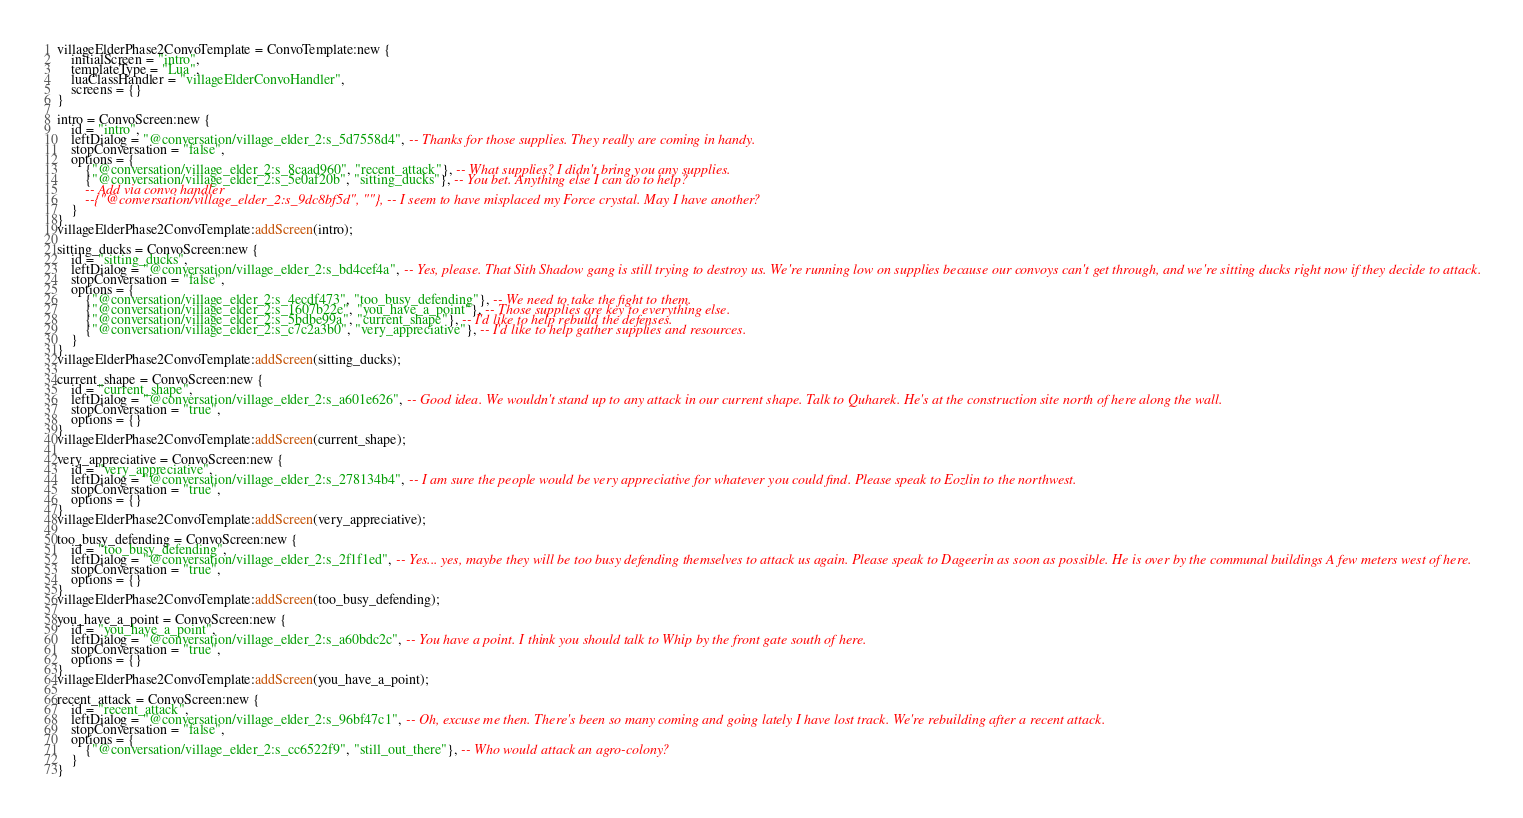<code> <loc_0><loc_0><loc_500><loc_500><_Lua_>villageElderPhase2ConvoTemplate = ConvoTemplate:new {
	initialScreen = "intro",
	templateType = "Lua",
	luaClassHandler = "villageElderConvoHandler",
	screens = {}
}

intro = ConvoScreen:new {
	id = "intro",
	leftDialog = "@conversation/village_elder_2:s_5d7558d4", -- Thanks for those supplies. They really are coming in handy.
	stopConversation = "false",
	options = {
		{"@conversation/village_elder_2:s_8caad960", "recent_attack"}, -- What supplies? I didn't bring you any supplies.
		{"@conversation/village_elder_2:s_5e0af20b", "sitting_ducks"}, -- You bet. Anything else I can do to help?
		-- Add via convo handler
		--{"@conversation/village_elder_2:s_9dc8bf5d", ""}, -- I seem to have misplaced my Force crystal. May I have another?
	}
}
villageElderPhase2ConvoTemplate:addScreen(intro);

sitting_ducks = ConvoScreen:new {
	id = "sitting_ducks",
	leftDialog = "@conversation/village_elder_2:s_bd4cef4a", -- Yes, please. That Sith Shadow gang is still trying to destroy us. We're running low on supplies because our convoys can't get through, and we're sitting ducks right now if they decide to attack.
	stopConversation = "false",
	options = {
		{"@conversation/village_elder_2:s_4ecdf473", "too_busy_defending"}, -- We need to take the fight to them.
		{"@conversation/village_elder_2:s_1607b22e", "you_have_a_point"}, -- Those supplies are key to everything else.
		{"@conversation/village_elder_2:s_5bdbe99a", "current_shape"}, -- I'd like to help rebuild the defenses.
		{"@conversation/village_elder_2:s_c7c2a3b0", "very_appreciative"}, -- I'd like to help gather supplies and resources.
	}
}
villageElderPhase2ConvoTemplate:addScreen(sitting_ducks);

current_shape = ConvoScreen:new {
	id = "current_shape",
	leftDialog = "@conversation/village_elder_2:s_a601e626", -- Good idea. We wouldn't stand up to any attack in our current shape. Talk to Quharek. He's at the construction site north of here along the wall.
	stopConversation = "true",
	options = {}
}
villageElderPhase2ConvoTemplate:addScreen(current_shape);

very_appreciative = ConvoScreen:new {
	id = "very_appreciative",
	leftDialog = "@conversation/village_elder_2:s_278134b4", -- I am sure the people would be very appreciative for whatever you could find. Please speak to Eozlin to the northwest.
	stopConversation = "true",
	options = {}
}
villageElderPhase2ConvoTemplate:addScreen(very_appreciative);

too_busy_defending = ConvoScreen:new {
	id = "too_busy_defending",
	leftDialog = "@conversation/village_elder_2:s_2f1f1ed", -- Yes... yes, maybe they will be too busy defending themselves to attack us again. Please speak to Dageerin as soon as possible. He is over by the communal buildings A few meters west of here.
	stopConversation = "true",
	options = {}
}
villageElderPhase2ConvoTemplate:addScreen(too_busy_defending);

you_have_a_point = ConvoScreen:new {
	id = "you_have_a_point",
	leftDialog = "@conversation/village_elder_2:s_a60bdc2c", -- You have a point. I think you should talk to Whip by the front gate south of here.
	stopConversation = "true",
	options = {}
}
villageElderPhase2ConvoTemplate:addScreen(you_have_a_point);

recent_attack = ConvoScreen:new {
	id = "recent_attack",
	leftDialog = "@conversation/village_elder_2:s_96bf47c1", -- Oh, excuse me then. There's been so many coming and going lately I have lost track. We're rebuilding after a recent attack.
	stopConversation = "false",
	options = {
		{"@conversation/village_elder_2:s_cc6522f9", "still_out_there"}, -- Who would attack an agro-colony?
	}
}</code> 